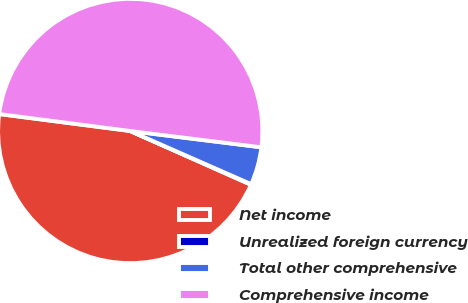Convert chart. <chart><loc_0><loc_0><loc_500><loc_500><pie_chart><fcel>Net income<fcel>Unrealized foreign currency<fcel>Total other comprehensive<fcel>Comprehensive income<nl><fcel>45.38%<fcel>0.08%<fcel>4.62%<fcel>49.92%<nl></chart> 